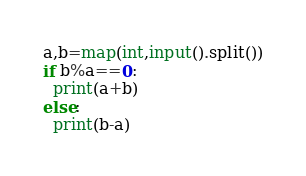<code> <loc_0><loc_0><loc_500><loc_500><_Python_>a,b=map(int,input().split())
if b%a==0:
  print(a+b)
else:
  print(b-a)
</code> 